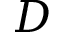Convert formula to latex. <formula><loc_0><loc_0><loc_500><loc_500>D</formula> 